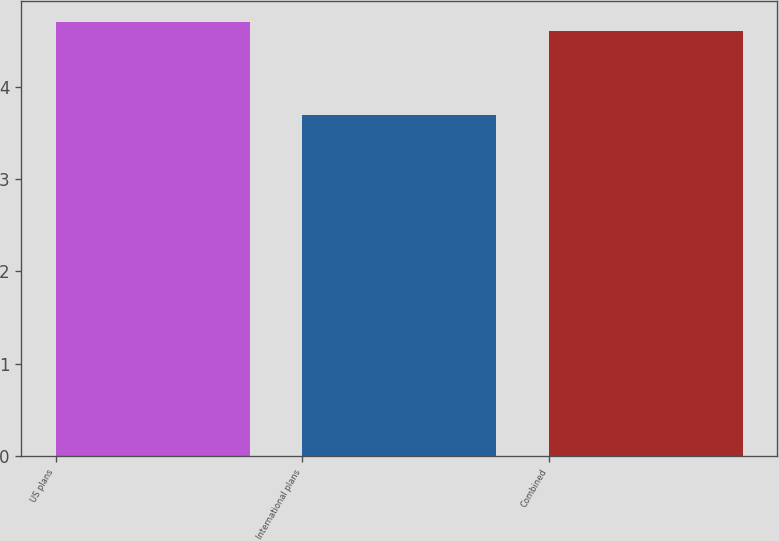Convert chart to OTSL. <chart><loc_0><loc_0><loc_500><loc_500><bar_chart><fcel>US plans<fcel>International plans<fcel>Combined<nl><fcel>4.7<fcel>3.7<fcel>4.6<nl></chart> 